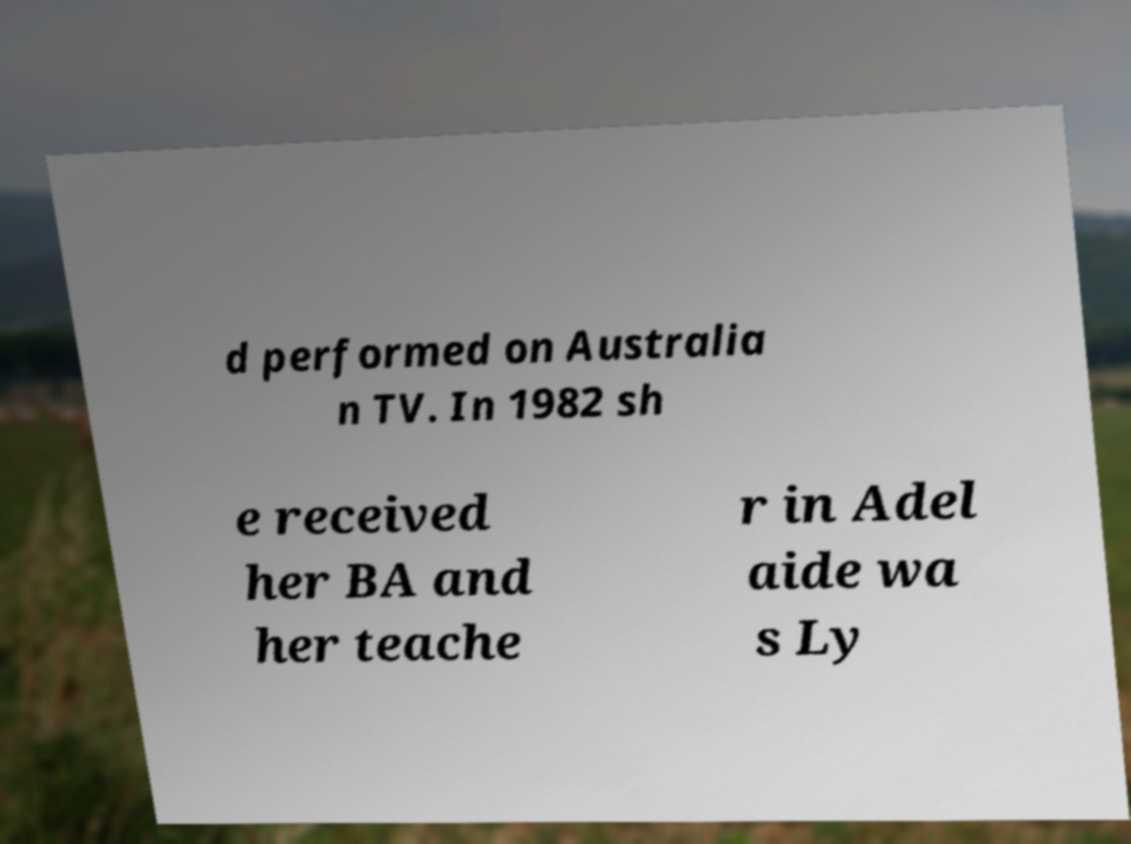What messages or text are displayed in this image? I need them in a readable, typed format. d performed on Australia n TV. In 1982 sh e received her BA and her teache r in Adel aide wa s Ly 